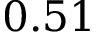Convert formula to latex. <formula><loc_0><loc_0><loc_500><loc_500>0 . 5 1</formula> 